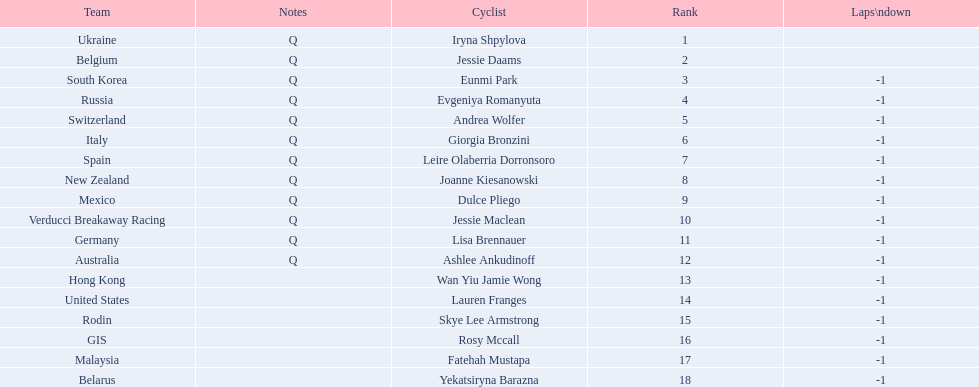Who are all the cyclists? Iryna Shpylova, Jessie Daams, Eunmi Park, Evgeniya Romanyuta, Andrea Wolfer, Giorgia Bronzini, Leire Olaberria Dorronsoro, Joanne Kiesanowski, Dulce Pliego, Jessie Maclean, Lisa Brennauer, Ashlee Ankudinoff, Wan Yiu Jamie Wong, Lauren Franges, Skye Lee Armstrong, Rosy Mccall, Fatehah Mustapa, Yekatsiryna Barazna. What were their ranks? 1, 2, 3, 4, 5, 6, 7, 8, 9, 10, 11, 12, 13, 14, 15, 16, 17, 18. Could you help me parse every detail presented in this table? {'header': ['Team', 'Notes', 'Cyclist', 'Rank', 'Laps\\ndown'], 'rows': [['Ukraine', 'Q', 'Iryna Shpylova', '1', ''], ['Belgium', 'Q', 'Jessie Daams', '2', ''], ['South Korea', 'Q', 'Eunmi Park', '3', '-1'], ['Russia', 'Q', 'Evgeniya Romanyuta', '4', '-1'], ['Switzerland', 'Q', 'Andrea Wolfer', '5', '-1'], ['Italy', 'Q', 'Giorgia Bronzini', '6', '-1'], ['Spain', 'Q', 'Leire Olaberria Dorronsoro', '7', '-1'], ['New Zealand', 'Q', 'Joanne Kiesanowski', '8', '-1'], ['Mexico', 'Q', 'Dulce Pliego', '9', '-1'], ['Verducci Breakaway Racing', 'Q', 'Jessie Maclean', '10', '-1'], ['Germany', 'Q', 'Lisa Brennauer', '11', '-1'], ['Australia', 'Q', 'Ashlee Ankudinoff', '12', '-1'], ['Hong Kong', '', 'Wan Yiu Jamie Wong', '13', '-1'], ['United States', '', 'Lauren Franges', '14', '-1'], ['Rodin', '', 'Skye Lee Armstrong', '15', '-1'], ['GIS', '', 'Rosy Mccall', '16', '-1'], ['Malaysia', '', 'Fatehah Mustapa', '17', '-1'], ['Belarus', '', 'Yekatsiryna Barazna', '18', '-1']]} Who was ranked highest? Iryna Shpylova. 